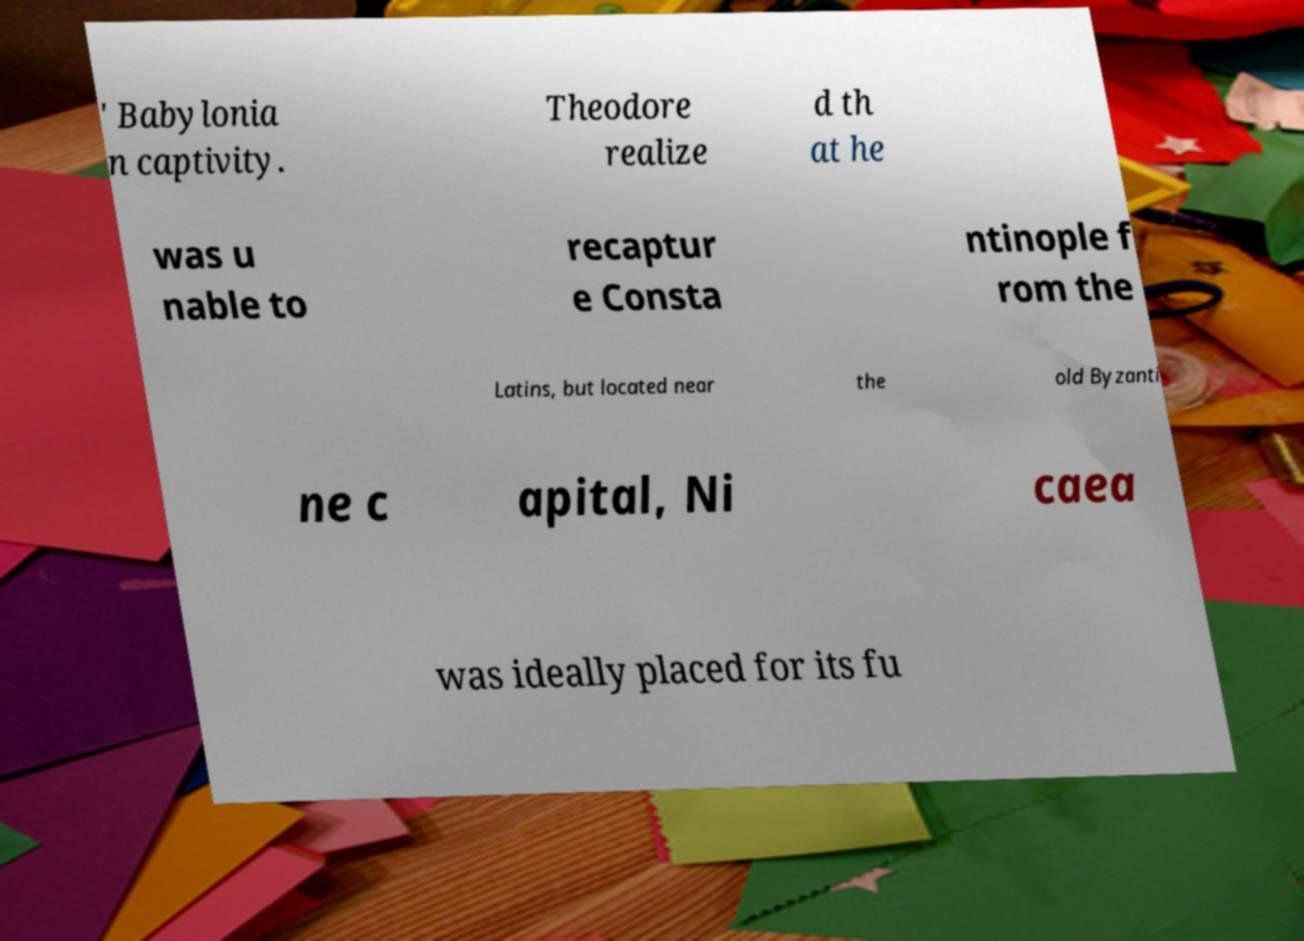Could you extract and type out the text from this image? ' Babylonia n captivity. Theodore realize d th at he was u nable to recaptur e Consta ntinople f rom the Latins, but located near the old Byzanti ne c apital, Ni caea was ideally placed for its fu 